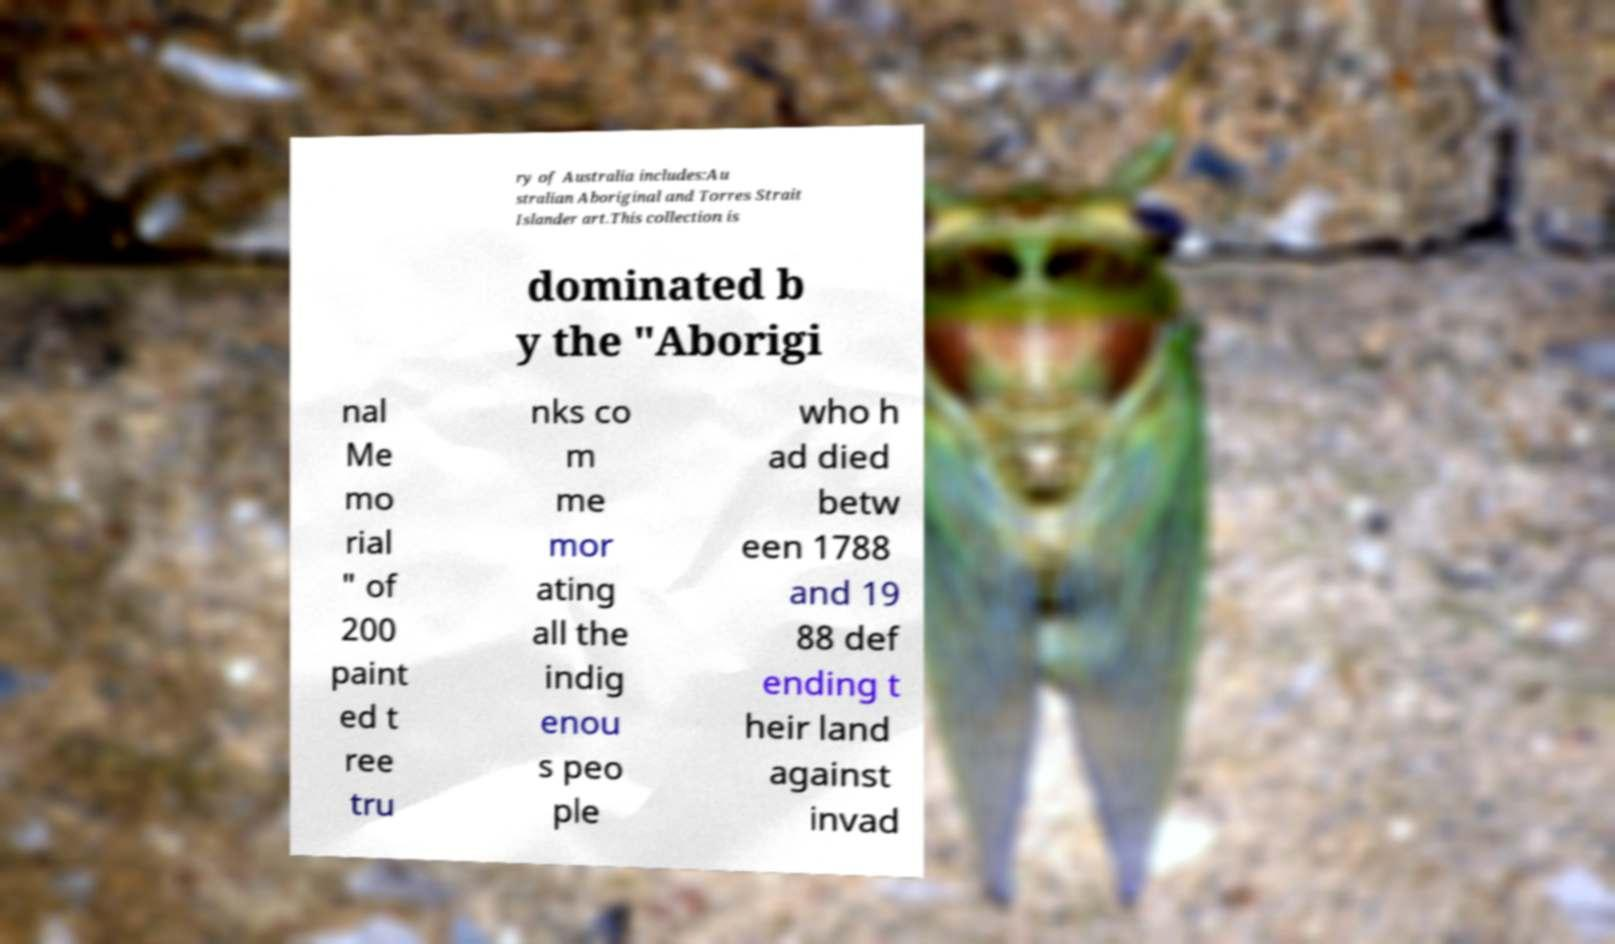Can you read and provide the text displayed in the image?This photo seems to have some interesting text. Can you extract and type it out for me? ry of Australia includes:Au stralian Aboriginal and Torres Strait Islander art.This collection is dominated b y the "Aborigi nal Me mo rial " of 200 paint ed t ree tru nks co m me mor ating all the indig enou s peo ple who h ad died betw een 1788 and 19 88 def ending t heir land against invad 